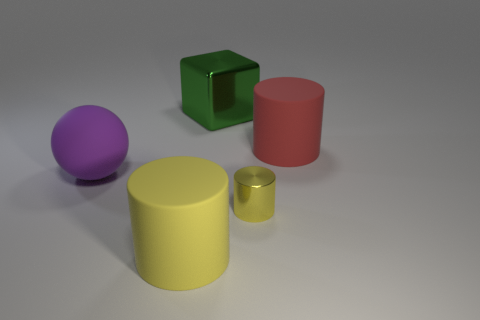Add 5 tiny yellow things. How many objects exist? 10 Subtract all cubes. How many objects are left? 4 Add 5 blue shiny cylinders. How many blue shiny cylinders exist? 5 Subtract 0 brown balls. How many objects are left? 5 Subtract all red matte blocks. Subtract all yellow metal objects. How many objects are left? 4 Add 5 big purple rubber balls. How many big purple rubber balls are left? 6 